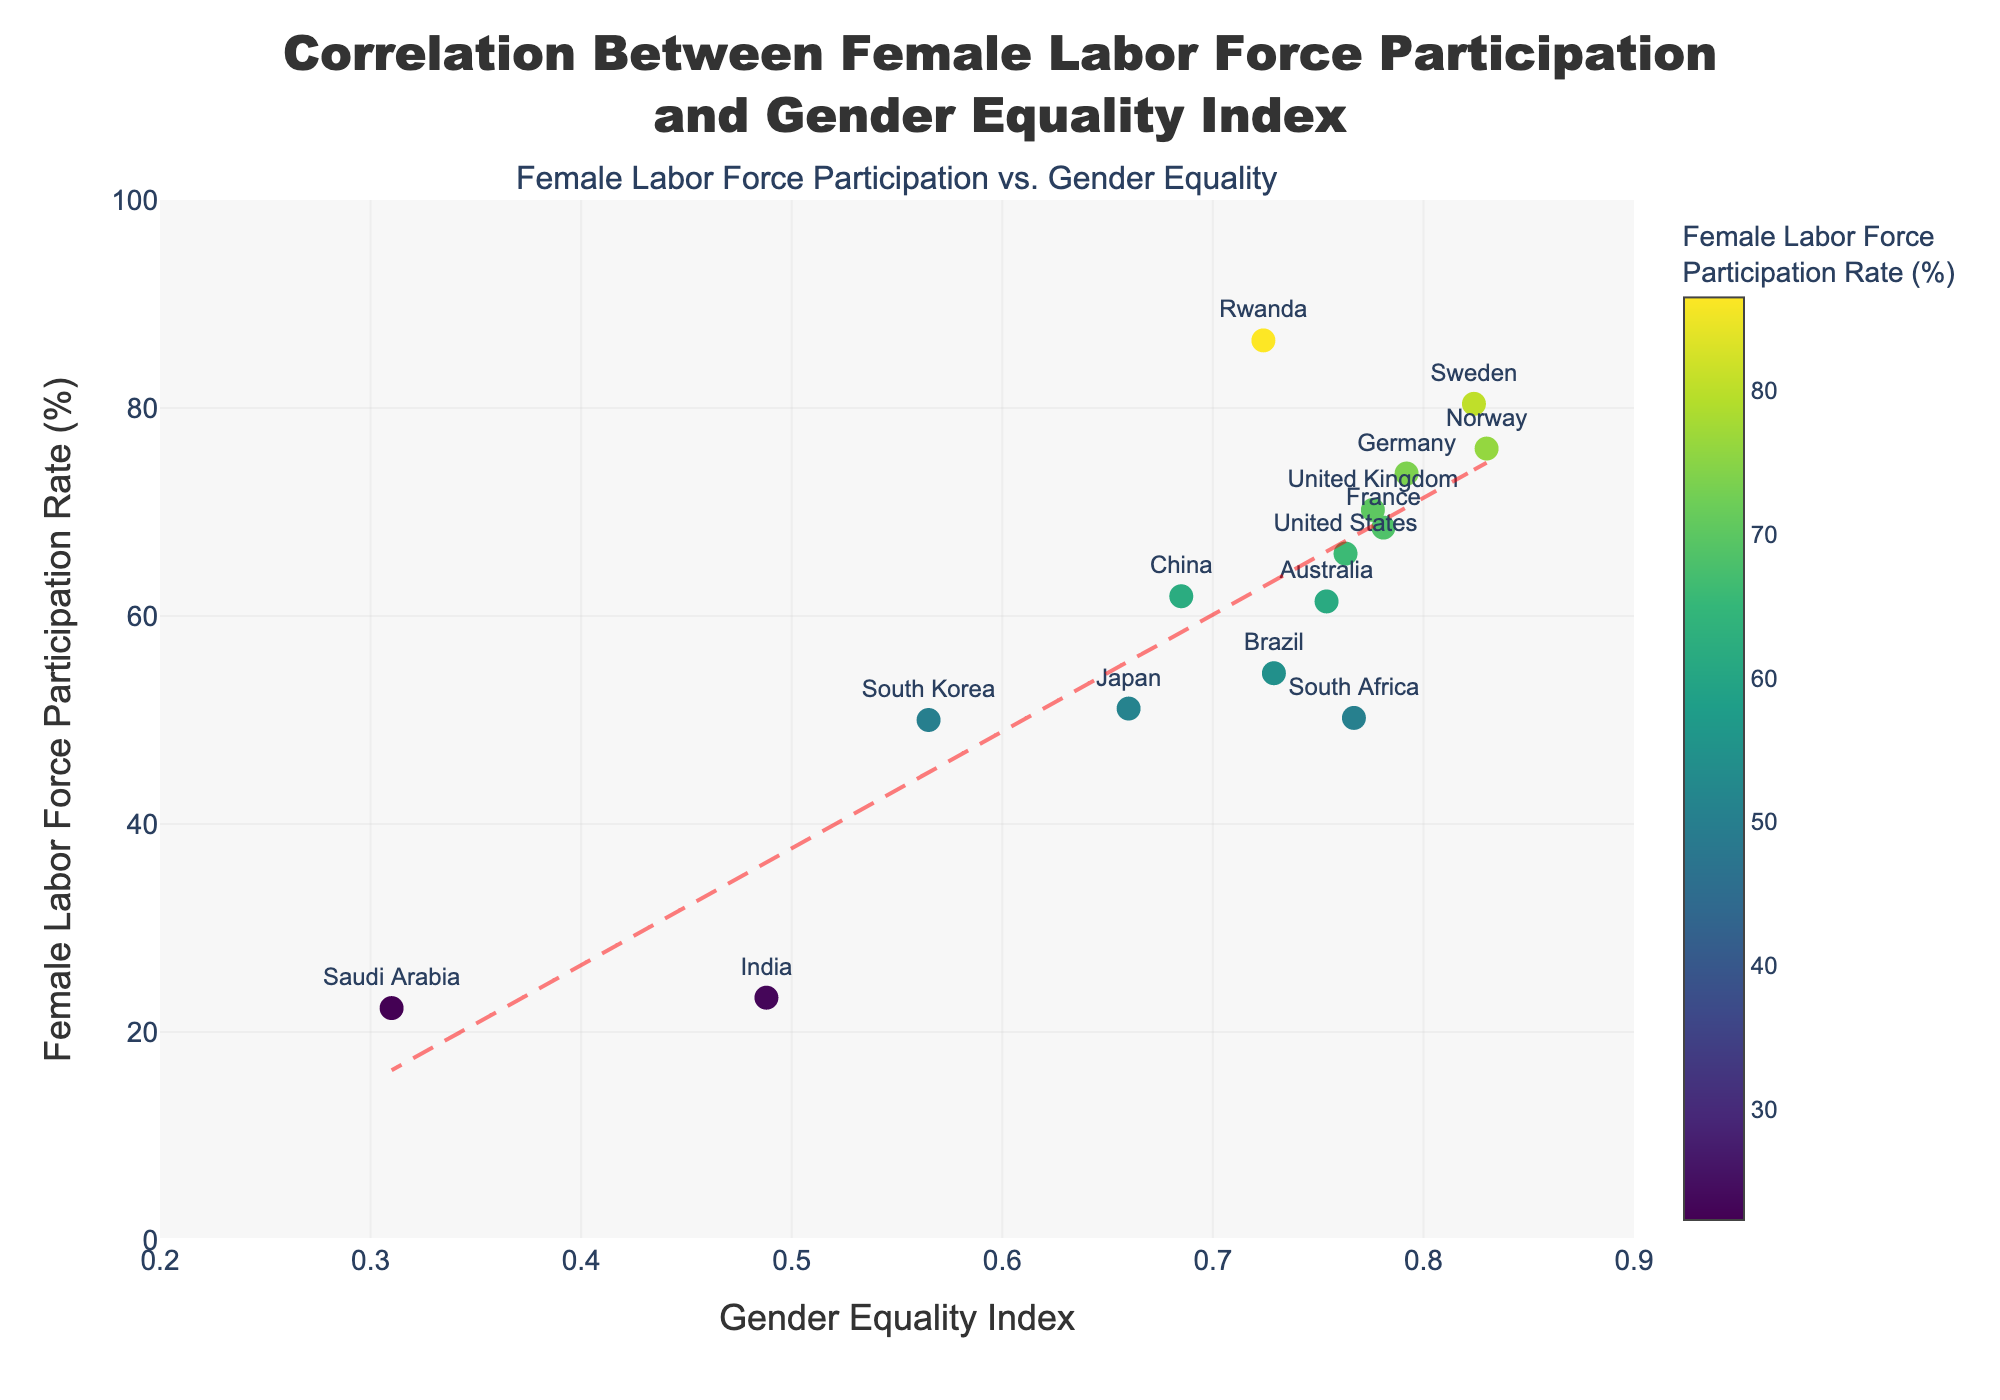What is the title of the scatter plot? The title of the scatter plot is located at the top center. It reads "Correlation Between Female Labor Force Participation and Gender Equality Index".
Answer: Correlation Between Female Labor Force Participation and Gender Equality Index Which country has the highest Female Labor Force Participation Rate? From the scatter plot, observe the position of the points on the y-axis, which represents the Female Labor Force Participation Rate. The highest point corresponds to Rwanda with a rate of 86.5%.
Answer: Rwanda What is the range of the Gender Equality Index shown in the plot? Look at the x-axis of the scatter plot. The range starts from 0.2 and goes up to 0.9.
Answer: 0.2 to 0.9 Which countries have a Gender Equality Index greater than 0.80? Find the points on the scatter plot where the x-axis value is greater than 0.80. The countries meeting this criterion are Sweden and Norway.
Answer: Sweden, Norway How does the trend line in the scatter plot relate the Female Labor Force Participation Rate to the Gender Equality Index? The trend line is a dashed red line that shows a positive correlation between the Female Labor Force Participation Rate and the Gender Equality Index, indicating that higher Gender Equality Index values are associated with higher Female Labor Force Participation Rates.
Answer: Positive correlation Which country has a higher Female Labor Force Participation Rate, Japan or Brazil? Find the points corresponding to Japan and Brazil on the scatter plot. Compare their y-axis values. Japan’s rate is 51.1%, while Brazil’s rate is 54.5%.
Answer: Brazil What is the Female Labor Force Participation Rate for the United States? Locate the point labeled "United States" and check its position on the y-axis. The Female Labor Force Participation Rate for the United States is 66.0%.
Answer: 66.0% Compare the Gender Equality Index of the United Kingdom and Germany. Which is higher, and by how much? Locate the points for the United Kingdom and Germany on the x-axis. The United Kingdom has a Gender Equality Index of 0.776, while Germany has an index of 0.792. The difference is 0.792 - 0.776 = 0.016.
Answer: Germany by 0.016 What is the average Female Labor Force Participation Rate of the countries with a Gender Equality Index below 0.6? Identify the points with a Gender Equality Index below 0.6: South Korea (50.0%), Saudi Arabia (22.3%), and India (23.3%). Calculate the average: (50.0 + 22.3 + 23.3) / 3 ≈ 31.87%.
Answer: 31.87% 